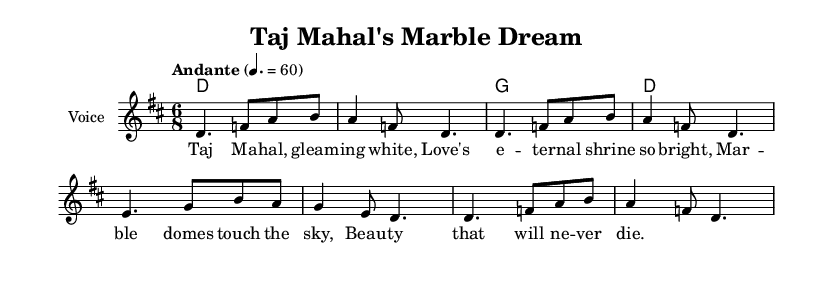What is the key signature of this music? The key signature is D major, which has two sharps (F# and C#). This can be determined by looking at the key indicated in the global section of the code.
Answer: D major What is the time signature of this music? The time signature is 6/8, which is stated explicitly in the global section of the code. This indicates there are six eighth notes per measure.
Answer: 6/8 What is the tempo marking for this piece? The tempo marking is "Andante" with a metronome marking of 60 beats per minute. This is specified in the global section of the code where tempo instructions are provided.
Answer: Andante How many measures are in the melody? The melody consists of 8 measures, which can be counted by observing the individual segments divided by the vertical bar lines in the melody part of the music notation.
Answer: 8 What is the first note of the melody? The first note of the melody is D. This can be identified as the first note in the relative notation, where the melody starts with the note D in the first measure.
Answer: D Which architectural landmark is celebrated in this song? The song celebrates the Taj Mahal. This is clear from the title mentioned in the header of the music notation.
Answer: Taj Mahal What is the theme of the lyrics? The theme of the lyrics includes love and beauty, as described in the lines mentioning "Love's eternal shrine so bright" and "Beauty that will never die." This illustrates the emotional connection to the landmark.
Answer: Love and beauty 